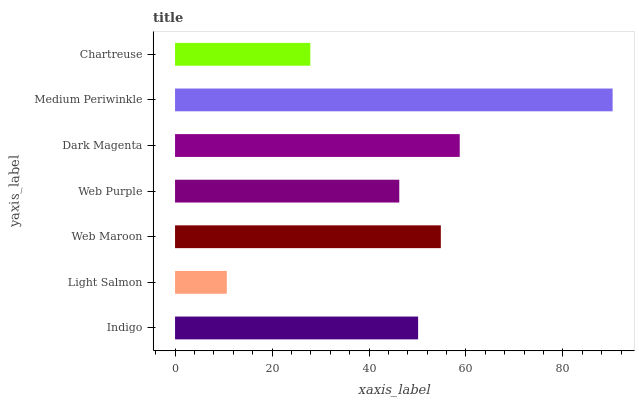Is Light Salmon the minimum?
Answer yes or no. Yes. Is Medium Periwinkle the maximum?
Answer yes or no. Yes. Is Web Maroon the minimum?
Answer yes or no. No. Is Web Maroon the maximum?
Answer yes or no. No. Is Web Maroon greater than Light Salmon?
Answer yes or no. Yes. Is Light Salmon less than Web Maroon?
Answer yes or no. Yes. Is Light Salmon greater than Web Maroon?
Answer yes or no. No. Is Web Maroon less than Light Salmon?
Answer yes or no. No. Is Indigo the high median?
Answer yes or no. Yes. Is Indigo the low median?
Answer yes or no. Yes. Is Web Purple the high median?
Answer yes or no. No. Is Light Salmon the low median?
Answer yes or no. No. 